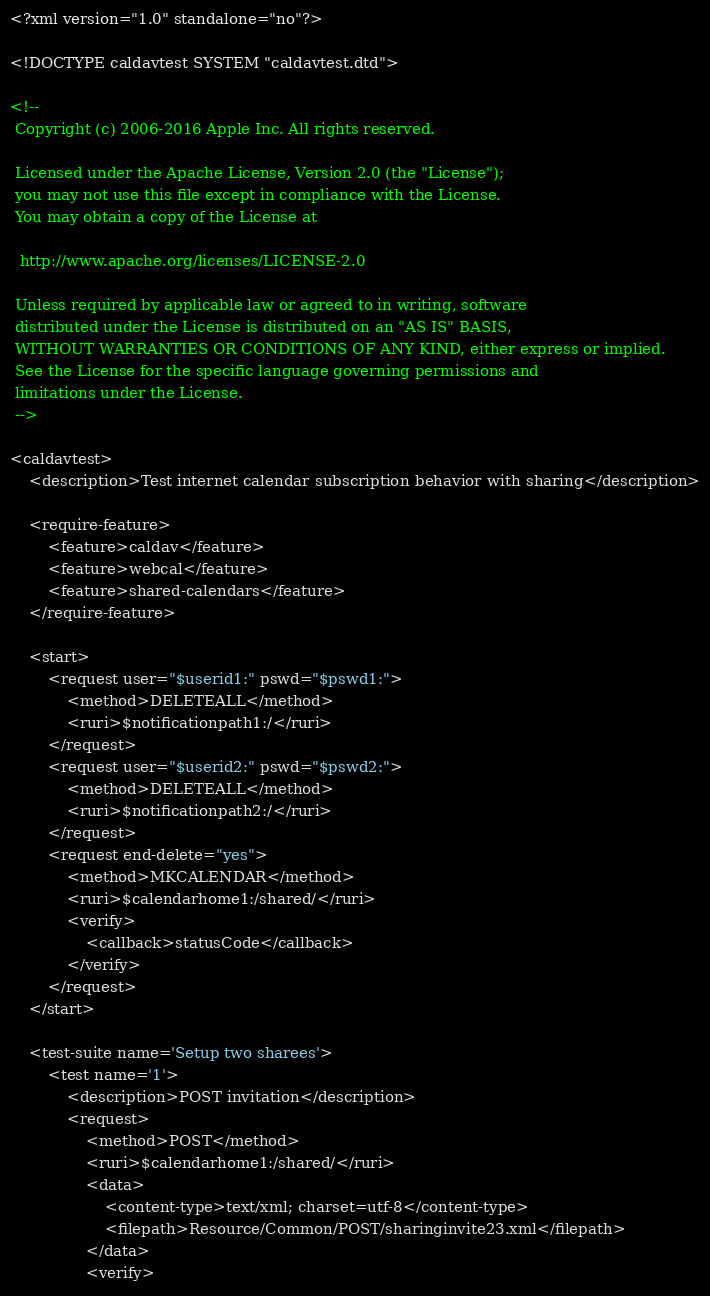Convert code to text. <code><loc_0><loc_0><loc_500><loc_500><_XML_><?xml version="1.0" standalone="no"?>

<!DOCTYPE caldavtest SYSTEM "caldavtest.dtd">

<!--
 Copyright (c) 2006-2016 Apple Inc. All rights reserved.

 Licensed under the Apache License, Version 2.0 (the "License");
 you may not use this file except in compliance with the License.
 You may obtain a copy of the License at

  http://www.apache.org/licenses/LICENSE-2.0

 Unless required by applicable law or agreed to in writing, software
 distributed under the License is distributed on an "AS IS" BASIS,
 WITHOUT WARRANTIES OR CONDITIONS OF ANY KIND, either express or implied.
 See the License for the specific language governing permissions and
 limitations under the License.
 -->

<caldavtest>
	<description>Test internet calendar subscription behavior with sharing</description>

	<require-feature>
		<feature>caldav</feature>
		<feature>webcal</feature>
		<feature>shared-calendars</feature>
	</require-feature>

	<start>
		<request user="$userid1:" pswd="$pswd1:">
			<method>DELETEALL</method>
			<ruri>$notificationpath1:/</ruri>
		</request>
		<request user="$userid2:" pswd="$pswd2:">
			<method>DELETEALL</method>
			<ruri>$notificationpath2:/</ruri>
		</request>
		<request end-delete="yes">
			<method>MKCALENDAR</method>
			<ruri>$calendarhome1:/shared/</ruri>
			<verify>
				<callback>statusCode</callback>
			</verify>
		</request>
	</start>
	
	<test-suite name='Setup two sharees'>
		<test name='1'>
			<description>POST invitation</description>
			<request>
				<method>POST</method>
				<ruri>$calendarhome1:/shared/</ruri>
				<data>
					<content-type>text/xml; charset=utf-8</content-type>
					<filepath>Resource/Common/POST/sharinginvite23.xml</filepath>
				</data>
				<verify></code> 